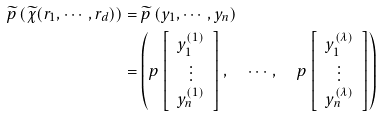Convert formula to latex. <formula><loc_0><loc_0><loc_500><loc_500>\widetilde { p } \left ( \widetilde { \chi } ( r _ { 1 } , \cdots , r _ { d } ) \right ) & = \widetilde { p } \left ( y _ { 1 } , \cdots , y _ { n } \right ) \\ & = \left ( p \left [ \begin{array} { c } y _ { 1 } ^ { ( 1 ) } \\ \vdots \\ y _ { n } ^ { ( 1 ) } \end{array} \right ] , \quad \cdots , \quad p \left [ \begin{array} { c } y _ { 1 } ^ { ( \lambda ) } \\ \vdots \\ y _ { n } ^ { ( \lambda ) } \end{array} \right ] \right )</formula> 